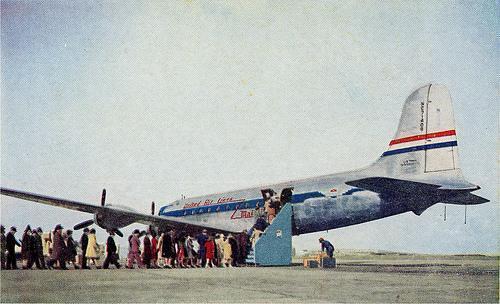How many planes are shown?
Give a very brief answer. 1. How many blades are on a propeller?
Give a very brief answer. 3. How many propellers are visible?
Give a very brief answer. 2. 